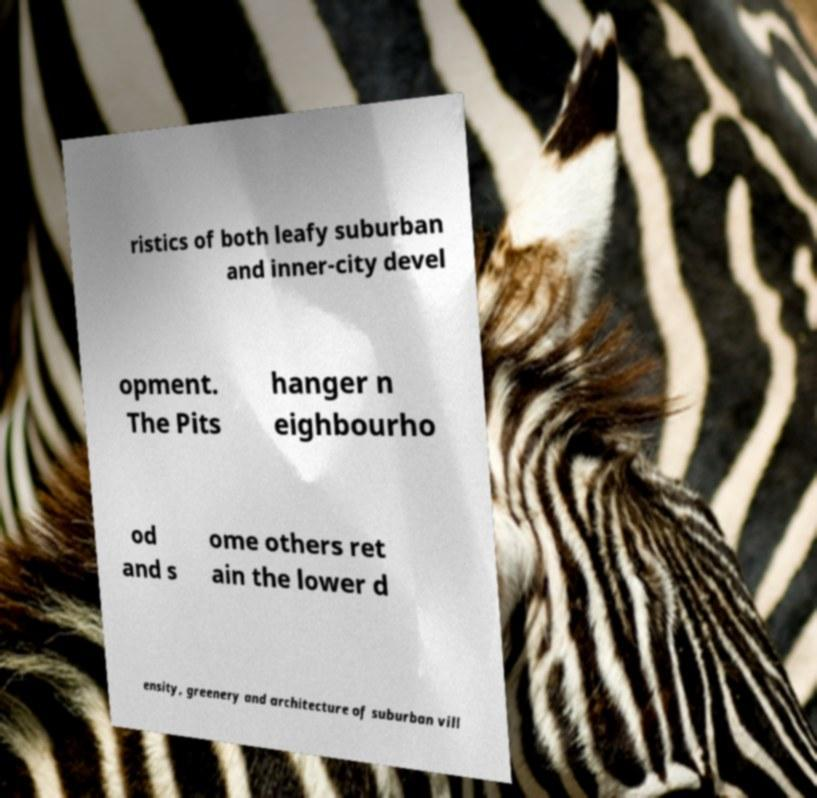Can you read and provide the text displayed in the image?This photo seems to have some interesting text. Can you extract and type it out for me? ristics of both leafy suburban and inner-city devel opment. The Pits hanger n eighbourho od and s ome others ret ain the lower d ensity, greenery and architecture of suburban vill 